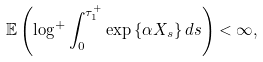<formula> <loc_0><loc_0><loc_500><loc_500>\mathbb { E } \left ( \log ^ { + } \int _ { 0 } ^ { \tau ^ { + } _ { 1 } } \exp \left \{ \alpha X _ { s } \right \} d s \right ) < \infty ,</formula> 